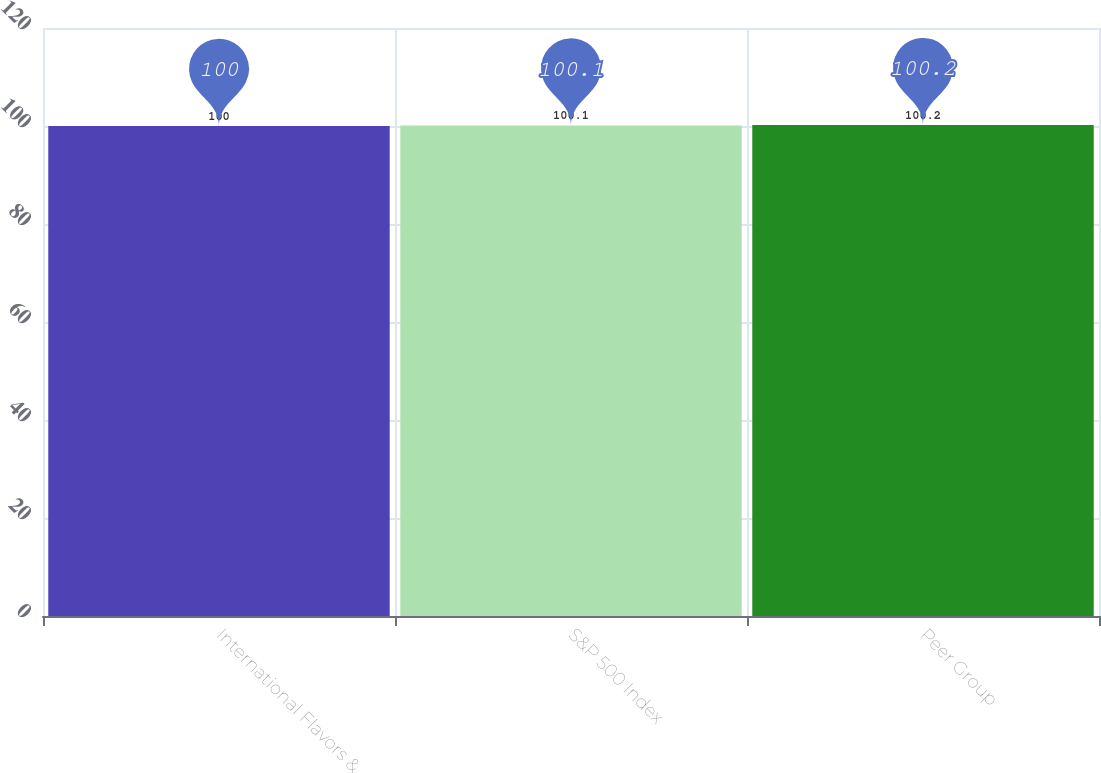Convert chart. <chart><loc_0><loc_0><loc_500><loc_500><bar_chart><fcel>International Flavors &<fcel>S&P 500 Index<fcel>Peer Group<nl><fcel>100<fcel>100.1<fcel>100.2<nl></chart> 